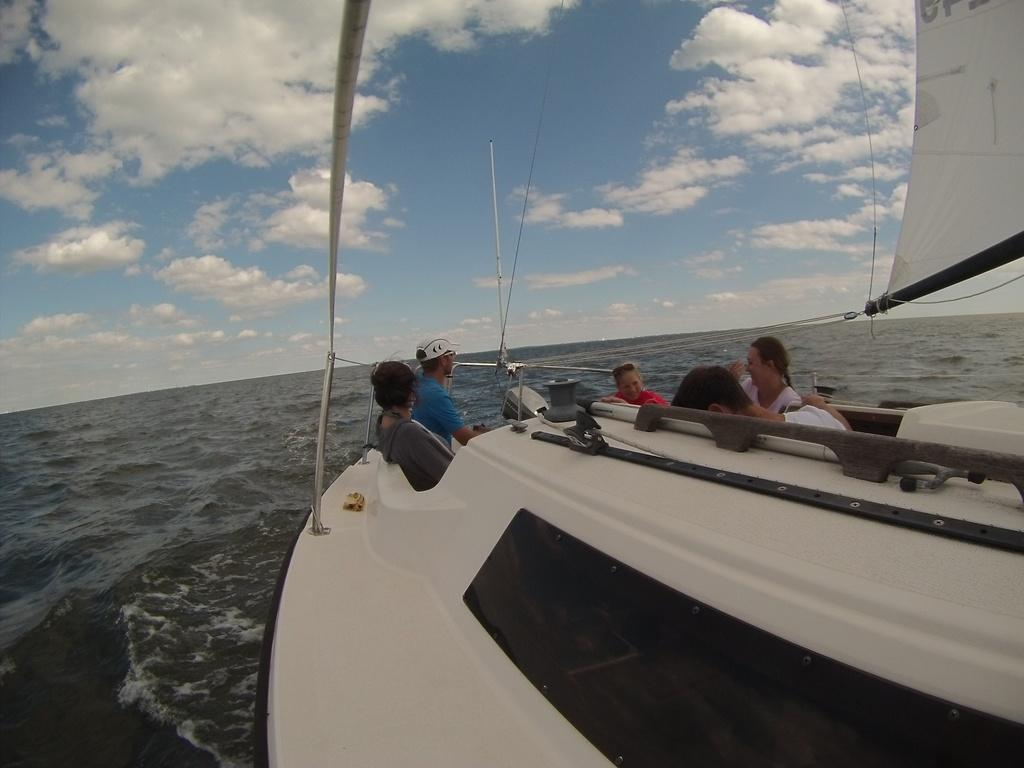What are the people in the image doing? The people in the image are sitting in a boat. What is the boat floating on in the image? There is water visible in the image. How would you describe the sky in the image? The sky is blue and cloudy in the image. What type of doctor is attending to the people in the boat in the image? There is no doctor present in the image; it only shows people sitting in a boat on water. How are the people in the boat measuring the depth of the water in the image? There is no indication in the image that the people are measuring the depth of the water; they are simply sitting in the boat. 